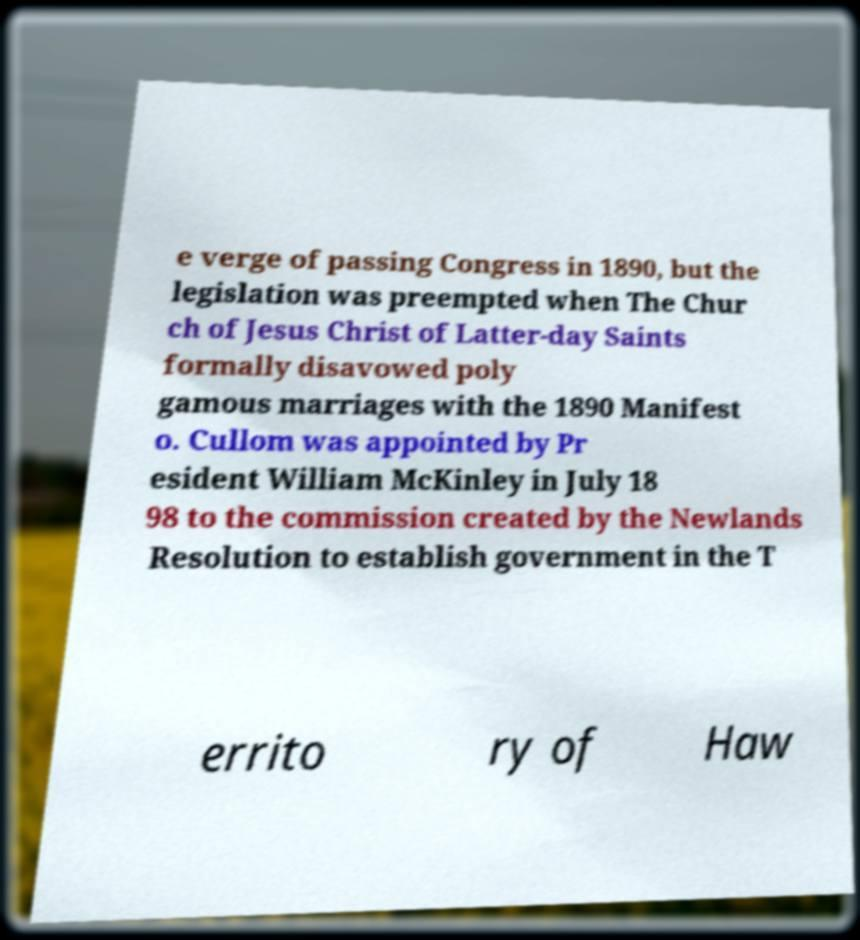I need the written content from this picture converted into text. Can you do that? e verge of passing Congress in 1890, but the legislation was preempted when The Chur ch of Jesus Christ of Latter-day Saints formally disavowed poly gamous marriages with the 1890 Manifest o. Cullom was appointed by Pr esident William McKinley in July 18 98 to the commission created by the Newlands Resolution to establish government in the T errito ry of Haw 